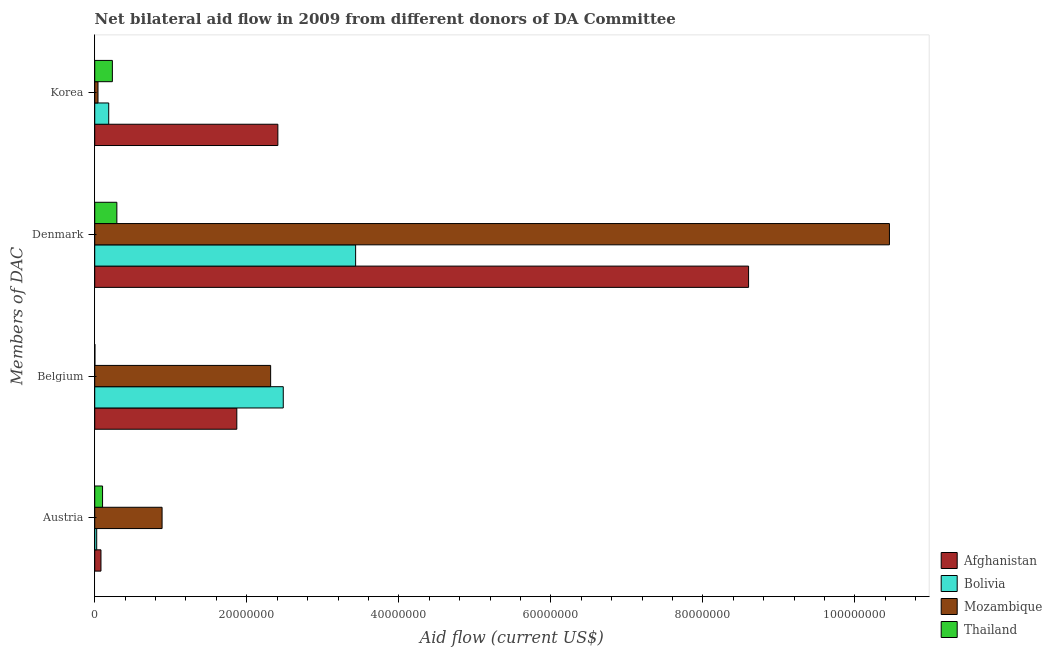How many different coloured bars are there?
Offer a terse response. 4. How many groups of bars are there?
Ensure brevity in your answer.  4. Are the number of bars per tick equal to the number of legend labels?
Your answer should be compact. Yes. Are the number of bars on each tick of the Y-axis equal?
Give a very brief answer. Yes. What is the label of the 1st group of bars from the top?
Your answer should be compact. Korea. What is the amount of aid given by belgium in Afghanistan?
Give a very brief answer. 1.87e+07. Across all countries, what is the maximum amount of aid given by belgium?
Keep it short and to the point. 2.48e+07. Across all countries, what is the minimum amount of aid given by belgium?
Give a very brief answer. 2.00e+04. In which country was the amount of aid given by korea maximum?
Give a very brief answer. Afghanistan. In which country was the amount of aid given by belgium minimum?
Your response must be concise. Thailand. What is the total amount of aid given by korea in the graph?
Make the answer very short. 2.87e+07. What is the difference between the amount of aid given by korea in Afghanistan and that in Bolivia?
Your answer should be compact. 2.22e+07. What is the difference between the amount of aid given by austria in Mozambique and the amount of aid given by korea in Bolivia?
Your answer should be very brief. 7.02e+06. What is the average amount of aid given by belgium per country?
Your answer should be very brief. 1.67e+07. What is the difference between the amount of aid given by belgium and amount of aid given by denmark in Thailand?
Offer a very short reply. -2.89e+06. What is the ratio of the amount of aid given by austria in Thailand to that in Afghanistan?
Offer a terse response. 1.26. Is the amount of aid given by belgium in Bolivia less than that in Thailand?
Give a very brief answer. No. What is the difference between the highest and the second highest amount of aid given by belgium?
Ensure brevity in your answer.  1.66e+06. What is the difference between the highest and the lowest amount of aid given by belgium?
Offer a terse response. 2.48e+07. What does the 1st bar from the top in Denmark represents?
Your answer should be compact. Thailand. What does the 4th bar from the bottom in Austria represents?
Your response must be concise. Thailand. Are all the bars in the graph horizontal?
Give a very brief answer. Yes. How many countries are there in the graph?
Your answer should be compact. 4. Are the values on the major ticks of X-axis written in scientific E-notation?
Make the answer very short. No. Does the graph contain any zero values?
Offer a very short reply. No. Where does the legend appear in the graph?
Keep it short and to the point. Bottom right. How are the legend labels stacked?
Ensure brevity in your answer.  Vertical. What is the title of the graph?
Your answer should be compact. Net bilateral aid flow in 2009 from different donors of DA Committee. What is the label or title of the Y-axis?
Provide a succinct answer. Members of DAC. What is the Aid flow (current US$) of Afghanistan in Austria?
Give a very brief answer. 8.20e+05. What is the Aid flow (current US$) of Mozambique in Austria?
Your answer should be compact. 8.86e+06. What is the Aid flow (current US$) in Thailand in Austria?
Offer a very short reply. 1.03e+06. What is the Aid flow (current US$) in Afghanistan in Belgium?
Keep it short and to the point. 1.87e+07. What is the Aid flow (current US$) of Bolivia in Belgium?
Give a very brief answer. 2.48e+07. What is the Aid flow (current US$) of Mozambique in Belgium?
Make the answer very short. 2.31e+07. What is the Aid flow (current US$) in Thailand in Belgium?
Your answer should be compact. 2.00e+04. What is the Aid flow (current US$) in Afghanistan in Denmark?
Offer a very short reply. 8.60e+07. What is the Aid flow (current US$) of Bolivia in Denmark?
Your answer should be compact. 3.43e+07. What is the Aid flow (current US$) in Mozambique in Denmark?
Your answer should be very brief. 1.05e+08. What is the Aid flow (current US$) in Thailand in Denmark?
Provide a short and direct response. 2.91e+06. What is the Aid flow (current US$) in Afghanistan in Korea?
Your answer should be compact. 2.41e+07. What is the Aid flow (current US$) of Bolivia in Korea?
Your answer should be compact. 1.84e+06. What is the Aid flow (current US$) in Thailand in Korea?
Provide a short and direct response. 2.32e+06. Across all Members of DAC, what is the maximum Aid flow (current US$) of Afghanistan?
Ensure brevity in your answer.  8.60e+07. Across all Members of DAC, what is the maximum Aid flow (current US$) of Bolivia?
Provide a short and direct response. 3.43e+07. Across all Members of DAC, what is the maximum Aid flow (current US$) of Mozambique?
Offer a terse response. 1.05e+08. Across all Members of DAC, what is the maximum Aid flow (current US$) of Thailand?
Offer a terse response. 2.91e+06. Across all Members of DAC, what is the minimum Aid flow (current US$) of Afghanistan?
Give a very brief answer. 8.20e+05. Across all Members of DAC, what is the minimum Aid flow (current US$) of Mozambique?
Your response must be concise. 4.30e+05. Across all Members of DAC, what is the minimum Aid flow (current US$) in Thailand?
Keep it short and to the point. 2.00e+04. What is the total Aid flow (current US$) in Afghanistan in the graph?
Give a very brief answer. 1.30e+08. What is the total Aid flow (current US$) in Bolivia in the graph?
Provide a succinct answer. 6.12e+07. What is the total Aid flow (current US$) of Mozambique in the graph?
Give a very brief answer. 1.37e+08. What is the total Aid flow (current US$) in Thailand in the graph?
Provide a short and direct response. 6.28e+06. What is the difference between the Aid flow (current US$) in Afghanistan in Austria and that in Belgium?
Offer a very short reply. -1.79e+07. What is the difference between the Aid flow (current US$) in Bolivia in Austria and that in Belgium?
Ensure brevity in your answer.  -2.45e+07. What is the difference between the Aid flow (current US$) in Mozambique in Austria and that in Belgium?
Offer a terse response. -1.43e+07. What is the difference between the Aid flow (current US$) in Thailand in Austria and that in Belgium?
Offer a terse response. 1.01e+06. What is the difference between the Aid flow (current US$) of Afghanistan in Austria and that in Denmark?
Your answer should be compact. -8.52e+07. What is the difference between the Aid flow (current US$) in Bolivia in Austria and that in Denmark?
Make the answer very short. -3.41e+07. What is the difference between the Aid flow (current US$) of Mozambique in Austria and that in Denmark?
Offer a very short reply. -9.57e+07. What is the difference between the Aid flow (current US$) of Thailand in Austria and that in Denmark?
Make the answer very short. -1.88e+06. What is the difference between the Aid flow (current US$) of Afghanistan in Austria and that in Korea?
Provide a succinct answer. -2.33e+07. What is the difference between the Aid flow (current US$) of Bolivia in Austria and that in Korea?
Offer a terse response. -1.58e+06. What is the difference between the Aid flow (current US$) in Mozambique in Austria and that in Korea?
Provide a succinct answer. 8.43e+06. What is the difference between the Aid flow (current US$) of Thailand in Austria and that in Korea?
Give a very brief answer. -1.29e+06. What is the difference between the Aid flow (current US$) of Afghanistan in Belgium and that in Denmark?
Your answer should be very brief. -6.73e+07. What is the difference between the Aid flow (current US$) of Bolivia in Belgium and that in Denmark?
Your response must be concise. -9.52e+06. What is the difference between the Aid flow (current US$) of Mozambique in Belgium and that in Denmark?
Offer a very short reply. -8.14e+07. What is the difference between the Aid flow (current US$) in Thailand in Belgium and that in Denmark?
Ensure brevity in your answer.  -2.89e+06. What is the difference between the Aid flow (current US$) in Afghanistan in Belgium and that in Korea?
Your answer should be very brief. -5.40e+06. What is the difference between the Aid flow (current US$) of Bolivia in Belgium and that in Korea?
Provide a succinct answer. 2.30e+07. What is the difference between the Aid flow (current US$) of Mozambique in Belgium and that in Korea?
Ensure brevity in your answer.  2.27e+07. What is the difference between the Aid flow (current US$) of Thailand in Belgium and that in Korea?
Offer a very short reply. -2.30e+06. What is the difference between the Aid flow (current US$) in Afghanistan in Denmark and that in Korea?
Keep it short and to the point. 6.19e+07. What is the difference between the Aid flow (current US$) of Bolivia in Denmark and that in Korea?
Provide a short and direct response. 3.25e+07. What is the difference between the Aid flow (current US$) in Mozambique in Denmark and that in Korea?
Ensure brevity in your answer.  1.04e+08. What is the difference between the Aid flow (current US$) in Thailand in Denmark and that in Korea?
Your answer should be compact. 5.90e+05. What is the difference between the Aid flow (current US$) in Afghanistan in Austria and the Aid flow (current US$) in Bolivia in Belgium?
Ensure brevity in your answer.  -2.40e+07. What is the difference between the Aid flow (current US$) of Afghanistan in Austria and the Aid flow (current US$) of Mozambique in Belgium?
Your answer should be very brief. -2.23e+07. What is the difference between the Aid flow (current US$) of Afghanistan in Austria and the Aid flow (current US$) of Thailand in Belgium?
Ensure brevity in your answer.  8.00e+05. What is the difference between the Aid flow (current US$) in Bolivia in Austria and the Aid flow (current US$) in Mozambique in Belgium?
Your answer should be compact. -2.29e+07. What is the difference between the Aid flow (current US$) in Bolivia in Austria and the Aid flow (current US$) in Thailand in Belgium?
Offer a terse response. 2.40e+05. What is the difference between the Aid flow (current US$) in Mozambique in Austria and the Aid flow (current US$) in Thailand in Belgium?
Your answer should be very brief. 8.84e+06. What is the difference between the Aid flow (current US$) of Afghanistan in Austria and the Aid flow (current US$) of Bolivia in Denmark?
Offer a very short reply. -3.35e+07. What is the difference between the Aid flow (current US$) in Afghanistan in Austria and the Aid flow (current US$) in Mozambique in Denmark?
Ensure brevity in your answer.  -1.04e+08. What is the difference between the Aid flow (current US$) of Afghanistan in Austria and the Aid flow (current US$) of Thailand in Denmark?
Your response must be concise. -2.09e+06. What is the difference between the Aid flow (current US$) in Bolivia in Austria and the Aid flow (current US$) in Mozambique in Denmark?
Make the answer very short. -1.04e+08. What is the difference between the Aid flow (current US$) of Bolivia in Austria and the Aid flow (current US$) of Thailand in Denmark?
Keep it short and to the point. -2.65e+06. What is the difference between the Aid flow (current US$) in Mozambique in Austria and the Aid flow (current US$) in Thailand in Denmark?
Your answer should be very brief. 5.95e+06. What is the difference between the Aid flow (current US$) of Afghanistan in Austria and the Aid flow (current US$) of Bolivia in Korea?
Your answer should be compact. -1.02e+06. What is the difference between the Aid flow (current US$) of Afghanistan in Austria and the Aid flow (current US$) of Thailand in Korea?
Give a very brief answer. -1.50e+06. What is the difference between the Aid flow (current US$) of Bolivia in Austria and the Aid flow (current US$) of Thailand in Korea?
Keep it short and to the point. -2.06e+06. What is the difference between the Aid flow (current US$) in Mozambique in Austria and the Aid flow (current US$) in Thailand in Korea?
Provide a short and direct response. 6.54e+06. What is the difference between the Aid flow (current US$) in Afghanistan in Belgium and the Aid flow (current US$) in Bolivia in Denmark?
Your answer should be very brief. -1.56e+07. What is the difference between the Aid flow (current US$) in Afghanistan in Belgium and the Aid flow (current US$) in Mozambique in Denmark?
Make the answer very short. -8.58e+07. What is the difference between the Aid flow (current US$) of Afghanistan in Belgium and the Aid flow (current US$) of Thailand in Denmark?
Provide a short and direct response. 1.58e+07. What is the difference between the Aid flow (current US$) in Bolivia in Belgium and the Aid flow (current US$) in Mozambique in Denmark?
Your answer should be compact. -7.97e+07. What is the difference between the Aid flow (current US$) of Bolivia in Belgium and the Aid flow (current US$) of Thailand in Denmark?
Your answer should be very brief. 2.19e+07. What is the difference between the Aid flow (current US$) in Mozambique in Belgium and the Aid flow (current US$) in Thailand in Denmark?
Ensure brevity in your answer.  2.02e+07. What is the difference between the Aid flow (current US$) in Afghanistan in Belgium and the Aid flow (current US$) in Bolivia in Korea?
Your answer should be compact. 1.68e+07. What is the difference between the Aid flow (current US$) of Afghanistan in Belgium and the Aid flow (current US$) of Mozambique in Korea?
Ensure brevity in your answer.  1.83e+07. What is the difference between the Aid flow (current US$) of Afghanistan in Belgium and the Aid flow (current US$) of Thailand in Korea?
Ensure brevity in your answer.  1.64e+07. What is the difference between the Aid flow (current US$) of Bolivia in Belgium and the Aid flow (current US$) of Mozambique in Korea?
Your answer should be very brief. 2.44e+07. What is the difference between the Aid flow (current US$) in Bolivia in Belgium and the Aid flow (current US$) in Thailand in Korea?
Offer a terse response. 2.25e+07. What is the difference between the Aid flow (current US$) of Mozambique in Belgium and the Aid flow (current US$) of Thailand in Korea?
Ensure brevity in your answer.  2.08e+07. What is the difference between the Aid flow (current US$) of Afghanistan in Denmark and the Aid flow (current US$) of Bolivia in Korea?
Give a very brief answer. 8.42e+07. What is the difference between the Aid flow (current US$) in Afghanistan in Denmark and the Aid flow (current US$) in Mozambique in Korea?
Make the answer very short. 8.56e+07. What is the difference between the Aid flow (current US$) in Afghanistan in Denmark and the Aid flow (current US$) in Thailand in Korea?
Provide a succinct answer. 8.37e+07. What is the difference between the Aid flow (current US$) of Bolivia in Denmark and the Aid flow (current US$) of Mozambique in Korea?
Your answer should be compact. 3.39e+07. What is the difference between the Aid flow (current US$) of Bolivia in Denmark and the Aid flow (current US$) of Thailand in Korea?
Keep it short and to the point. 3.20e+07. What is the difference between the Aid flow (current US$) in Mozambique in Denmark and the Aid flow (current US$) in Thailand in Korea?
Your answer should be compact. 1.02e+08. What is the average Aid flow (current US$) in Afghanistan per Members of DAC?
Keep it short and to the point. 3.24e+07. What is the average Aid flow (current US$) of Bolivia per Members of DAC?
Make the answer very short. 1.53e+07. What is the average Aid flow (current US$) in Mozambique per Members of DAC?
Your response must be concise. 3.42e+07. What is the average Aid flow (current US$) of Thailand per Members of DAC?
Keep it short and to the point. 1.57e+06. What is the difference between the Aid flow (current US$) in Afghanistan and Aid flow (current US$) in Bolivia in Austria?
Your response must be concise. 5.60e+05. What is the difference between the Aid flow (current US$) of Afghanistan and Aid flow (current US$) of Mozambique in Austria?
Offer a very short reply. -8.04e+06. What is the difference between the Aid flow (current US$) of Bolivia and Aid flow (current US$) of Mozambique in Austria?
Give a very brief answer. -8.60e+06. What is the difference between the Aid flow (current US$) in Bolivia and Aid flow (current US$) in Thailand in Austria?
Offer a very short reply. -7.70e+05. What is the difference between the Aid flow (current US$) in Mozambique and Aid flow (current US$) in Thailand in Austria?
Your answer should be compact. 7.83e+06. What is the difference between the Aid flow (current US$) of Afghanistan and Aid flow (current US$) of Bolivia in Belgium?
Offer a very short reply. -6.11e+06. What is the difference between the Aid flow (current US$) of Afghanistan and Aid flow (current US$) of Mozambique in Belgium?
Give a very brief answer. -4.45e+06. What is the difference between the Aid flow (current US$) of Afghanistan and Aid flow (current US$) of Thailand in Belgium?
Your answer should be very brief. 1.87e+07. What is the difference between the Aid flow (current US$) in Bolivia and Aid flow (current US$) in Mozambique in Belgium?
Ensure brevity in your answer.  1.66e+06. What is the difference between the Aid flow (current US$) in Bolivia and Aid flow (current US$) in Thailand in Belgium?
Your answer should be very brief. 2.48e+07. What is the difference between the Aid flow (current US$) of Mozambique and Aid flow (current US$) of Thailand in Belgium?
Make the answer very short. 2.31e+07. What is the difference between the Aid flow (current US$) of Afghanistan and Aid flow (current US$) of Bolivia in Denmark?
Provide a short and direct response. 5.17e+07. What is the difference between the Aid flow (current US$) of Afghanistan and Aid flow (current US$) of Mozambique in Denmark?
Offer a terse response. -1.85e+07. What is the difference between the Aid flow (current US$) of Afghanistan and Aid flow (current US$) of Thailand in Denmark?
Make the answer very short. 8.31e+07. What is the difference between the Aid flow (current US$) of Bolivia and Aid flow (current US$) of Mozambique in Denmark?
Your answer should be compact. -7.02e+07. What is the difference between the Aid flow (current US$) of Bolivia and Aid flow (current US$) of Thailand in Denmark?
Keep it short and to the point. 3.14e+07. What is the difference between the Aid flow (current US$) of Mozambique and Aid flow (current US$) of Thailand in Denmark?
Give a very brief answer. 1.02e+08. What is the difference between the Aid flow (current US$) in Afghanistan and Aid flow (current US$) in Bolivia in Korea?
Your answer should be very brief. 2.22e+07. What is the difference between the Aid flow (current US$) in Afghanistan and Aid flow (current US$) in Mozambique in Korea?
Your answer should be very brief. 2.37e+07. What is the difference between the Aid flow (current US$) in Afghanistan and Aid flow (current US$) in Thailand in Korea?
Give a very brief answer. 2.18e+07. What is the difference between the Aid flow (current US$) of Bolivia and Aid flow (current US$) of Mozambique in Korea?
Make the answer very short. 1.41e+06. What is the difference between the Aid flow (current US$) of Bolivia and Aid flow (current US$) of Thailand in Korea?
Ensure brevity in your answer.  -4.80e+05. What is the difference between the Aid flow (current US$) in Mozambique and Aid flow (current US$) in Thailand in Korea?
Keep it short and to the point. -1.89e+06. What is the ratio of the Aid flow (current US$) of Afghanistan in Austria to that in Belgium?
Keep it short and to the point. 0.04. What is the ratio of the Aid flow (current US$) in Bolivia in Austria to that in Belgium?
Your response must be concise. 0.01. What is the ratio of the Aid flow (current US$) of Mozambique in Austria to that in Belgium?
Offer a terse response. 0.38. What is the ratio of the Aid flow (current US$) in Thailand in Austria to that in Belgium?
Provide a short and direct response. 51.5. What is the ratio of the Aid flow (current US$) in Afghanistan in Austria to that in Denmark?
Provide a short and direct response. 0.01. What is the ratio of the Aid flow (current US$) in Bolivia in Austria to that in Denmark?
Make the answer very short. 0.01. What is the ratio of the Aid flow (current US$) in Mozambique in Austria to that in Denmark?
Your response must be concise. 0.08. What is the ratio of the Aid flow (current US$) of Thailand in Austria to that in Denmark?
Give a very brief answer. 0.35. What is the ratio of the Aid flow (current US$) of Afghanistan in Austria to that in Korea?
Provide a succinct answer. 0.03. What is the ratio of the Aid flow (current US$) of Bolivia in Austria to that in Korea?
Provide a short and direct response. 0.14. What is the ratio of the Aid flow (current US$) in Mozambique in Austria to that in Korea?
Your answer should be very brief. 20.6. What is the ratio of the Aid flow (current US$) in Thailand in Austria to that in Korea?
Offer a terse response. 0.44. What is the ratio of the Aid flow (current US$) of Afghanistan in Belgium to that in Denmark?
Ensure brevity in your answer.  0.22. What is the ratio of the Aid flow (current US$) of Bolivia in Belgium to that in Denmark?
Give a very brief answer. 0.72. What is the ratio of the Aid flow (current US$) in Mozambique in Belgium to that in Denmark?
Your response must be concise. 0.22. What is the ratio of the Aid flow (current US$) of Thailand in Belgium to that in Denmark?
Offer a very short reply. 0.01. What is the ratio of the Aid flow (current US$) in Afghanistan in Belgium to that in Korea?
Your answer should be very brief. 0.78. What is the ratio of the Aid flow (current US$) in Bolivia in Belgium to that in Korea?
Provide a succinct answer. 13.48. What is the ratio of the Aid flow (current US$) in Mozambique in Belgium to that in Korea?
Your answer should be very brief. 53.81. What is the ratio of the Aid flow (current US$) of Thailand in Belgium to that in Korea?
Offer a very short reply. 0.01. What is the ratio of the Aid flow (current US$) in Afghanistan in Denmark to that in Korea?
Make the answer very short. 3.57. What is the ratio of the Aid flow (current US$) in Bolivia in Denmark to that in Korea?
Offer a very short reply. 18.65. What is the ratio of the Aid flow (current US$) of Mozambique in Denmark to that in Korea?
Offer a terse response. 243.12. What is the ratio of the Aid flow (current US$) in Thailand in Denmark to that in Korea?
Offer a very short reply. 1.25. What is the difference between the highest and the second highest Aid flow (current US$) of Afghanistan?
Offer a terse response. 6.19e+07. What is the difference between the highest and the second highest Aid flow (current US$) of Bolivia?
Ensure brevity in your answer.  9.52e+06. What is the difference between the highest and the second highest Aid flow (current US$) in Mozambique?
Your answer should be compact. 8.14e+07. What is the difference between the highest and the second highest Aid flow (current US$) of Thailand?
Your answer should be very brief. 5.90e+05. What is the difference between the highest and the lowest Aid flow (current US$) of Afghanistan?
Make the answer very short. 8.52e+07. What is the difference between the highest and the lowest Aid flow (current US$) in Bolivia?
Your response must be concise. 3.41e+07. What is the difference between the highest and the lowest Aid flow (current US$) in Mozambique?
Your answer should be compact. 1.04e+08. What is the difference between the highest and the lowest Aid flow (current US$) in Thailand?
Make the answer very short. 2.89e+06. 